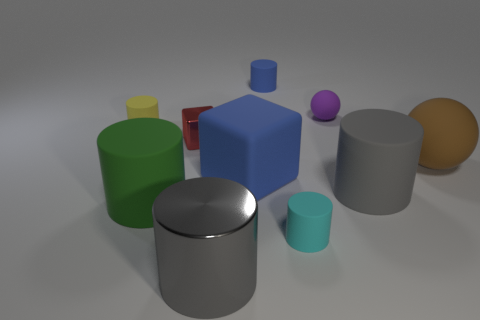Are there fewer green matte things right of the red metal object than large purple shiny spheres?
Make the answer very short. No. What number of tiny objects are cyan matte cylinders or red metallic cubes?
Offer a very short reply. 2. How big is the metallic cylinder?
Give a very brief answer. Large. How many large gray cylinders are to the left of the small red thing?
Provide a succinct answer. 0. There is another gray object that is the same shape as the big gray metallic object; what size is it?
Your response must be concise. Large. What is the size of the matte cylinder that is both to the right of the big block and on the left side of the cyan thing?
Provide a succinct answer. Small. There is a large matte block; does it have the same color as the tiny matte cylinder behind the small matte ball?
Offer a terse response. Yes. How many green things are either matte cylinders or tiny rubber cylinders?
Give a very brief answer. 1. What shape is the large green thing?
Keep it short and to the point. Cylinder. What number of other things are the same shape as the gray rubber thing?
Give a very brief answer. 5. 